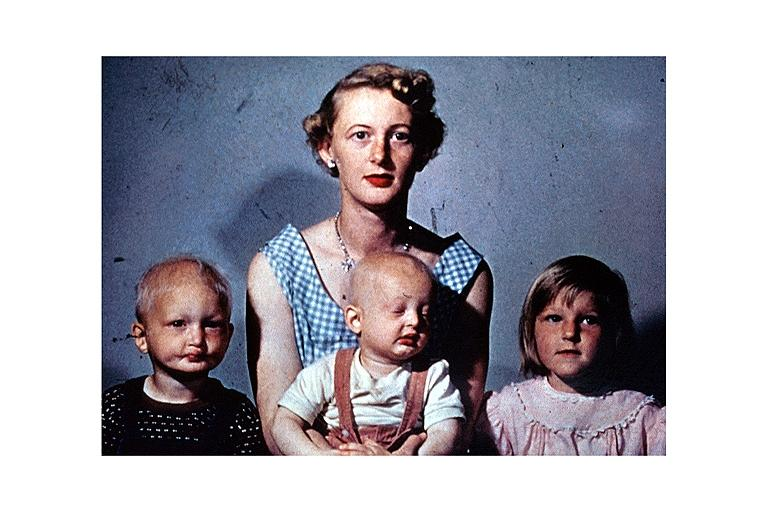where is this?
Answer the question using a single word or phrase. Oral 